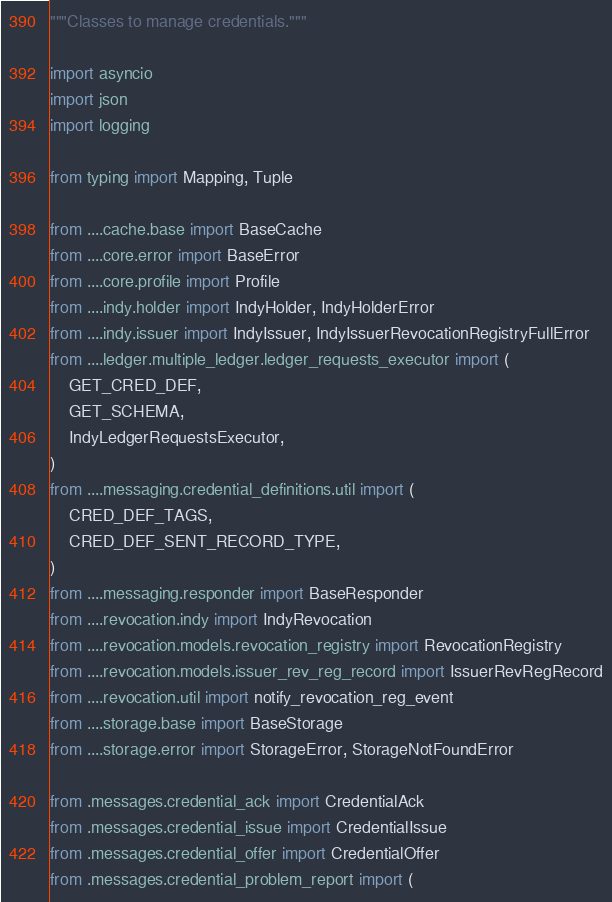Convert code to text. <code><loc_0><loc_0><loc_500><loc_500><_Python_>"""Classes to manage credentials."""

import asyncio
import json
import logging

from typing import Mapping, Tuple

from ....cache.base import BaseCache
from ....core.error import BaseError
from ....core.profile import Profile
from ....indy.holder import IndyHolder, IndyHolderError
from ....indy.issuer import IndyIssuer, IndyIssuerRevocationRegistryFullError
from ....ledger.multiple_ledger.ledger_requests_executor import (
    GET_CRED_DEF,
    GET_SCHEMA,
    IndyLedgerRequestsExecutor,
)
from ....messaging.credential_definitions.util import (
    CRED_DEF_TAGS,
    CRED_DEF_SENT_RECORD_TYPE,
)
from ....messaging.responder import BaseResponder
from ....revocation.indy import IndyRevocation
from ....revocation.models.revocation_registry import RevocationRegistry
from ....revocation.models.issuer_rev_reg_record import IssuerRevRegRecord
from ....revocation.util import notify_revocation_reg_event
from ....storage.base import BaseStorage
from ....storage.error import StorageError, StorageNotFoundError

from .messages.credential_ack import CredentialAck
from .messages.credential_issue import CredentialIssue
from .messages.credential_offer import CredentialOffer
from .messages.credential_problem_report import (</code> 